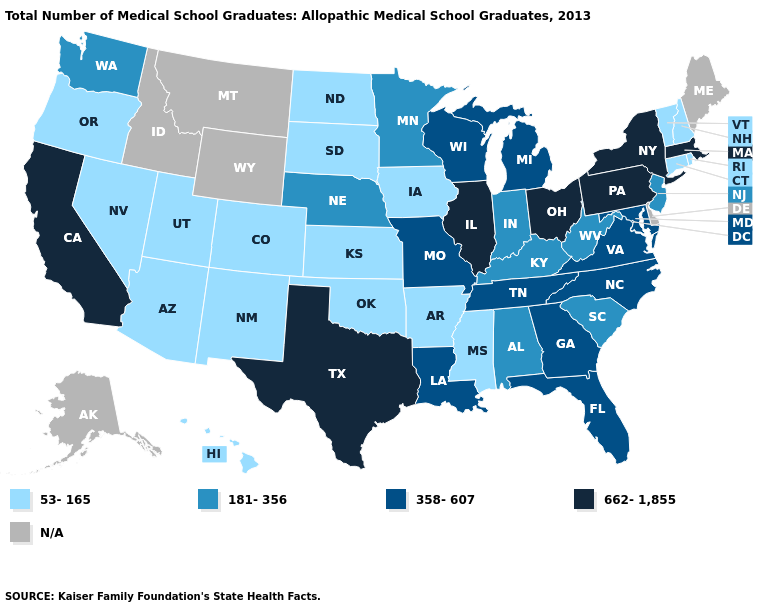What is the value of Arizona?
Short answer required. 53-165. Name the states that have a value in the range 53-165?
Keep it brief. Arizona, Arkansas, Colorado, Connecticut, Hawaii, Iowa, Kansas, Mississippi, Nevada, New Hampshire, New Mexico, North Dakota, Oklahoma, Oregon, Rhode Island, South Dakota, Utah, Vermont. Name the states that have a value in the range 53-165?
Quick response, please. Arizona, Arkansas, Colorado, Connecticut, Hawaii, Iowa, Kansas, Mississippi, Nevada, New Hampshire, New Mexico, North Dakota, Oklahoma, Oregon, Rhode Island, South Dakota, Utah, Vermont. What is the value of Texas?
Give a very brief answer. 662-1,855. What is the lowest value in states that border Indiana?
Short answer required. 181-356. Name the states that have a value in the range 181-356?
Be succinct. Alabama, Indiana, Kentucky, Minnesota, Nebraska, New Jersey, South Carolina, Washington, West Virginia. Name the states that have a value in the range 662-1,855?
Answer briefly. California, Illinois, Massachusetts, New York, Ohio, Pennsylvania, Texas. What is the lowest value in states that border Alabama?
Short answer required. 53-165. Name the states that have a value in the range 662-1,855?
Be succinct. California, Illinois, Massachusetts, New York, Ohio, Pennsylvania, Texas. Which states hav the highest value in the South?
Keep it brief. Texas. What is the lowest value in states that border Oregon?
Give a very brief answer. 53-165. Does California have the highest value in the West?
Be succinct. Yes. Which states have the highest value in the USA?
Quick response, please. California, Illinois, Massachusetts, New York, Ohio, Pennsylvania, Texas. What is the value of Idaho?
Keep it brief. N/A. What is the value of Louisiana?
Quick response, please. 358-607. 